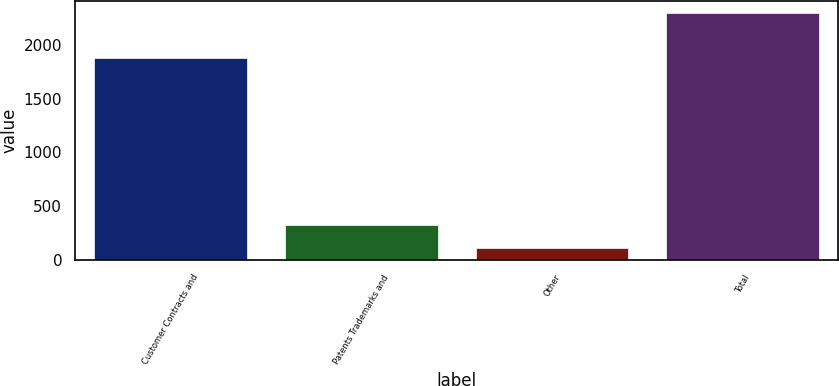Convert chart. <chart><loc_0><loc_0><loc_500><loc_500><bar_chart><fcel>Customer Contracts and<fcel>Patents Trademarks and<fcel>Other<fcel>Total<nl><fcel>1879<fcel>327.1<fcel>109<fcel>2290<nl></chart> 